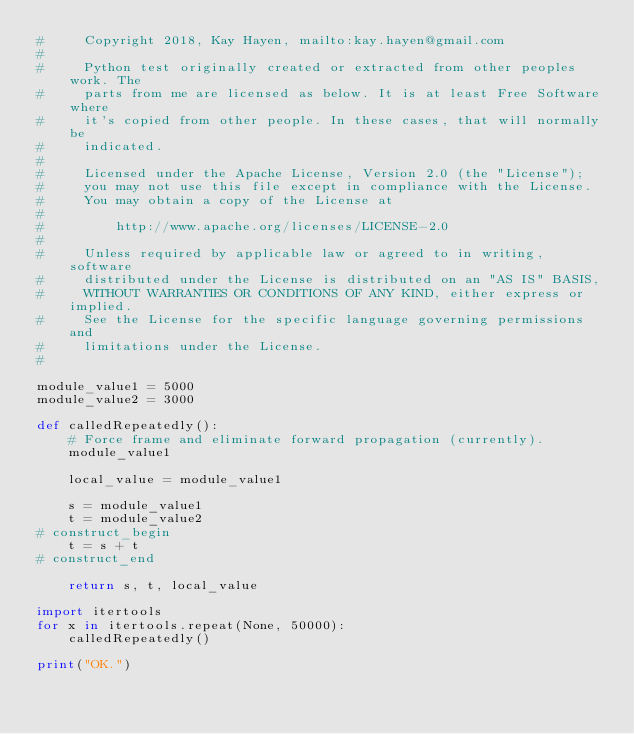Convert code to text. <code><loc_0><loc_0><loc_500><loc_500><_Python_>#     Copyright 2018, Kay Hayen, mailto:kay.hayen@gmail.com
#
#     Python test originally created or extracted from other peoples work. The
#     parts from me are licensed as below. It is at least Free Software where
#     it's copied from other people. In these cases, that will normally be
#     indicated.
#
#     Licensed under the Apache License, Version 2.0 (the "License");
#     you may not use this file except in compliance with the License.
#     You may obtain a copy of the License at
#
#         http://www.apache.org/licenses/LICENSE-2.0
#
#     Unless required by applicable law or agreed to in writing, software
#     distributed under the License is distributed on an "AS IS" BASIS,
#     WITHOUT WARRANTIES OR CONDITIONS OF ANY KIND, either express or implied.
#     See the License for the specific language governing permissions and
#     limitations under the License.
#

module_value1 = 5000
module_value2 = 3000

def calledRepeatedly():
    # Force frame and eliminate forward propagation (currently).
    module_value1

    local_value = module_value1

    s = module_value1
    t = module_value2
# construct_begin
    t = s + t
# construct_end

    return s, t, local_value

import itertools
for x in itertools.repeat(None, 50000):
    calledRepeatedly()

print("OK.")
</code> 